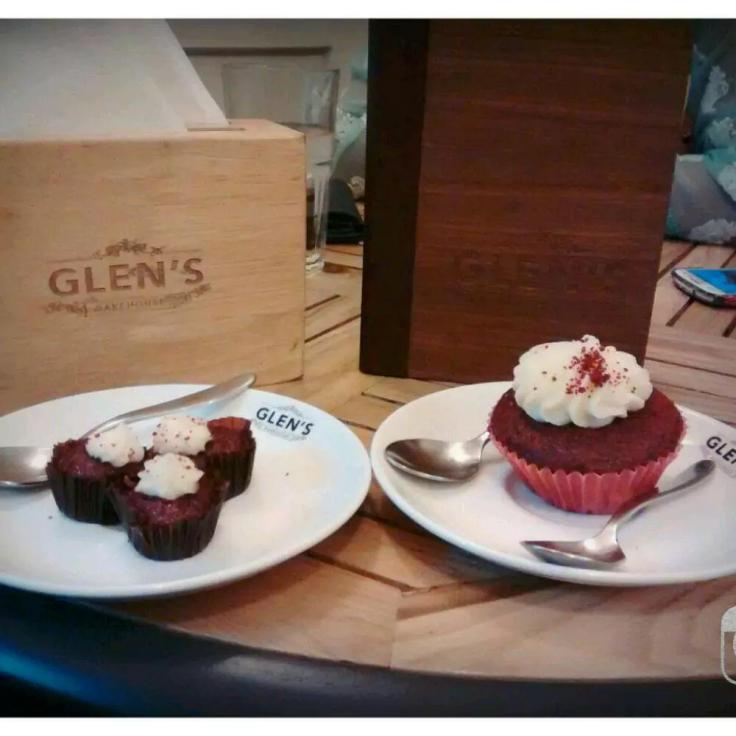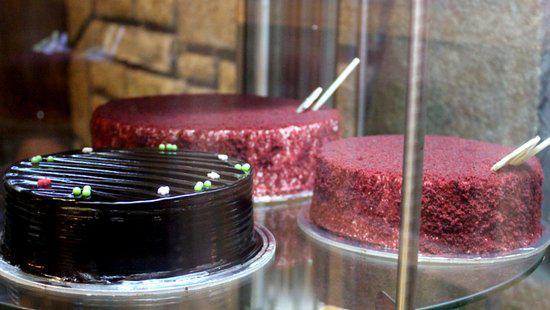The first image is the image on the left, the second image is the image on the right. Evaluate the accuracy of this statement regarding the images: "A glass case holds at least two whole, unsliced red velvet cakes.". Is it true? Answer yes or no. Yes. The first image is the image on the left, the second image is the image on the right. Considering the images on both sides, is "There is a plate of dessert on top of a wooden round table." valid? Answer yes or no. Yes. 